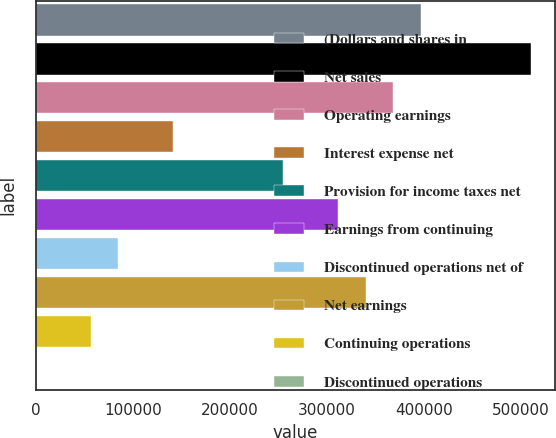<chart> <loc_0><loc_0><loc_500><loc_500><bar_chart><fcel>(Dollars and shares in<fcel>Net sales<fcel>Operating earnings<fcel>Interest expense net<fcel>Provision for income taxes net<fcel>Earnings from continuing<fcel>Discontinued operations net of<fcel>Net earnings<fcel>Continuing operations<fcel>Discontinued operations<nl><fcel>396480<fcel>509760<fcel>368160<fcel>141600<fcel>254880<fcel>311520<fcel>84960.1<fcel>339840<fcel>56640.1<fcel>0.11<nl></chart> 